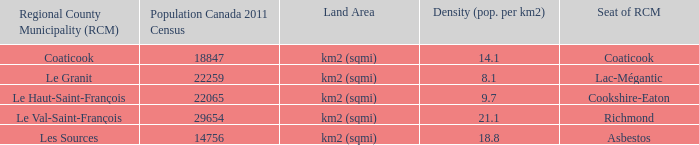What is the ground coverage for the rcm with a populace of 18847? Km2 (sqmi). 